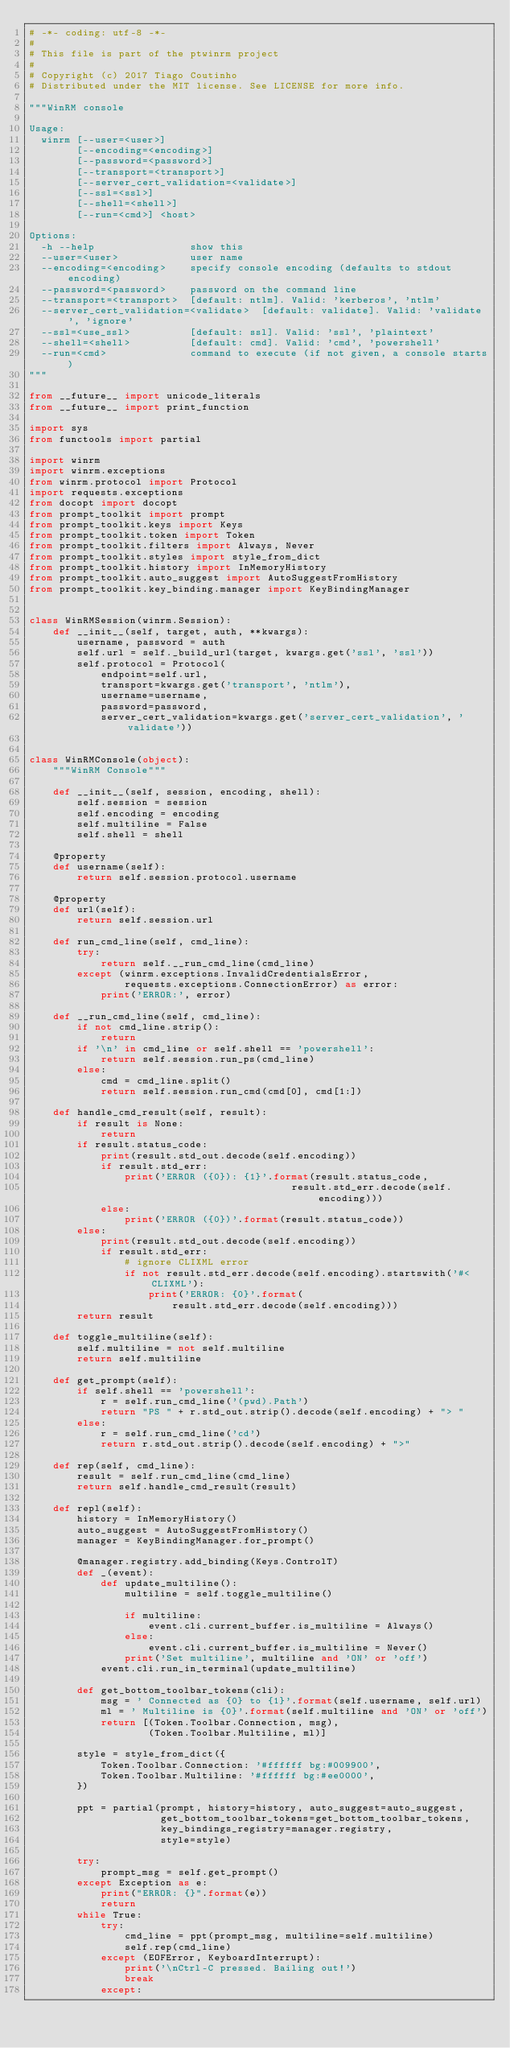<code> <loc_0><loc_0><loc_500><loc_500><_Python_># -*- coding: utf-8 -*-
#
# This file is part of the ptwinrm project
#
# Copyright (c) 2017 Tiago Coutinho
# Distributed under the MIT license. See LICENSE for more info.

"""WinRM console

Usage:
  winrm [--user=<user>]
        [--encoding=<encoding>]
        [--password=<password>]
        [--transport=<transport>]
        [--server_cert_validation=<validate>]
        [--ssl=<ssl>]
        [--shell=<shell>]
        [--run=<cmd>] <host>

Options:
  -h --help                show this
  --user=<user>            user name
  --encoding=<encoding>    specify console encoding (defaults to stdout encoding)
  --password=<password>    password on the command line
  --transport=<transport>  [default: ntlm]. Valid: 'kerberos', 'ntlm'
  --server_cert_validation=<validate>  [default: validate]. Valid: 'validate', 'ignore'
  --ssl=<use_ssl>          [default: ssl]. Valid: 'ssl', 'plaintext'
  --shell=<shell>          [default: cmd]. Valid: 'cmd', 'powershell'
  --run=<cmd>              command to execute (if not given, a console starts)
"""

from __future__ import unicode_literals
from __future__ import print_function

import sys
from functools import partial

import winrm
import winrm.exceptions
from winrm.protocol import Protocol
import requests.exceptions
from docopt import docopt
from prompt_toolkit import prompt
from prompt_toolkit.keys import Keys
from prompt_toolkit.token import Token
from prompt_toolkit.filters import Always, Never
from prompt_toolkit.styles import style_from_dict
from prompt_toolkit.history import InMemoryHistory
from prompt_toolkit.auto_suggest import AutoSuggestFromHistory
from prompt_toolkit.key_binding.manager import KeyBindingManager


class WinRMSession(winrm.Session):
    def __init__(self, target, auth, **kwargs):
        username, password = auth
        self.url = self._build_url(target, kwargs.get('ssl', 'ssl'))
        self.protocol = Protocol(
            endpoint=self.url,
            transport=kwargs.get('transport', 'ntlm'),
            username=username,
            password=password,
            server_cert_validation=kwargs.get('server_cert_validation', 'validate'))


class WinRMConsole(object):
    """WinRM Console"""

    def __init__(self, session, encoding, shell):
        self.session = session
        self.encoding = encoding
        self.multiline = False
        self.shell = shell

    @property
    def username(self):
        return self.session.protocol.username

    @property
    def url(self):
        return self.session.url

    def run_cmd_line(self, cmd_line):
        try:
            return self.__run_cmd_line(cmd_line)
        except (winrm.exceptions.InvalidCredentialsError,
                requests.exceptions.ConnectionError) as error:
            print('ERROR:', error)

    def __run_cmd_line(self, cmd_line):
        if not cmd_line.strip():
            return
        if '\n' in cmd_line or self.shell == 'powershell':
            return self.session.run_ps(cmd_line)
        else:
            cmd = cmd_line.split()
            return self.session.run_cmd(cmd[0], cmd[1:])

    def handle_cmd_result(self, result):
        if result is None:
            return
        if result.status_code:
            print(result.std_out.decode(self.encoding))
            if result.std_err:
                print('ERROR ({0}): {1}'.format(result.status_code,
                                            result.std_err.decode(self.encoding)))
            else:
                print('ERROR ({0})'.format(result.status_code))
        else:
            print(result.std_out.decode(self.encoding))
            if result.std_err:
                # ignore CLIXML error
                if not result.std_err.decode(self.encoding).startswith('#< CLIXML'):
                    print('ERROR: {0}'.format(
                        result.std_err.decode(self.encoding)))
        return result

    def toggle_multiline(self):
        self.multiline = not self.multiline
        return self.multiline

    def get_prompt(self):
        if self.shell == 'powershell':
            r = self.run_cmd_line('(pwd).Path')
            return "PS " + r.std_out.strip().decode(self.encoding) + "> "
        else:
            r = self.run_cmd_line('cd')
            return r.std_out.strip().decode(self.encoding) + ">"

    def rep(self, cmd_line):
        result = self.run_cmd_line(cmd_line)
        return self.handle_cmd_result(result)

    def repl(self):
        history = InMemoryHistory()
        auto_suggest = AutoSuggestFromHistory()
        manager = KeyBindingManager.for_prompt()

        @manager.registry.add_binding(Keys.ControlT)
        def _(event):
            def update_multiline():
                multiline = self.toggle_multiline()

                if multiline:
                    event.cli.current_buffer.is_multiline = Always()
                else:
                    event.cli.current_buffer.is_multiline = Never()
                print('Set multiline', multiline and 'ON' or 'off')
            event.cli.run_in_terminal(update_multiline)

        def get_bottom_toolbar_tokens(cli):
            msg = ' Connected as {0} to {1}'.format(self.username, self.url)
            ml = ' Multiline is {0}'.format(self.multiline and 'ON' or 'off')
            return [(Token.Toolbar.Connection, msg),
                    (Token.Toolbar.Multiline, ml)]

        style = style_from_dict({
            Token.Toolbar.Connection: '#ffffff bg:#009900',
            Token.Toolbar.Multiline: '#ffffff bg:#ee0000',
        })

        ppt = partial(prompt, history=history, auto_suggest=auto_suggest,
                      get_bottom_toolbar_tokens=get_bottom_toolbar_tokens,
                      key_bindings_registry=manager.registry,
                      style=style)

        try:
            prompt_msg = self.get_prompt()
        except Exception as e:
            print("ERROR: {}".format(e))
            return
        while True:
            try:
                cmd_line = ppt(prompt_msg, multiline=self.multiline)
                self.rep(cmd_line)
            except (EOFError, KeyboardInterrupt):
                print('\nCtrl-C pressed. Bailing out!')
                break
            except:</code> 